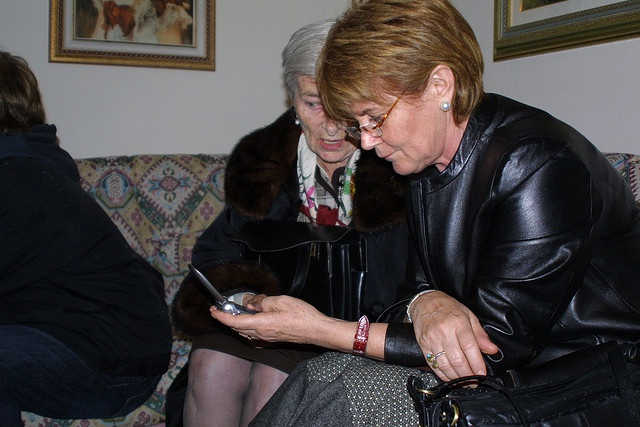Describe the objects in this image and their specific colors. I can see people in gray, black, and lightpink tones, people in gray, black, and darkgray tones, people in gray and black tones, couch in gray, black, and darkgray tones, and handbag in gray, black, and darkblue tones in this image. 